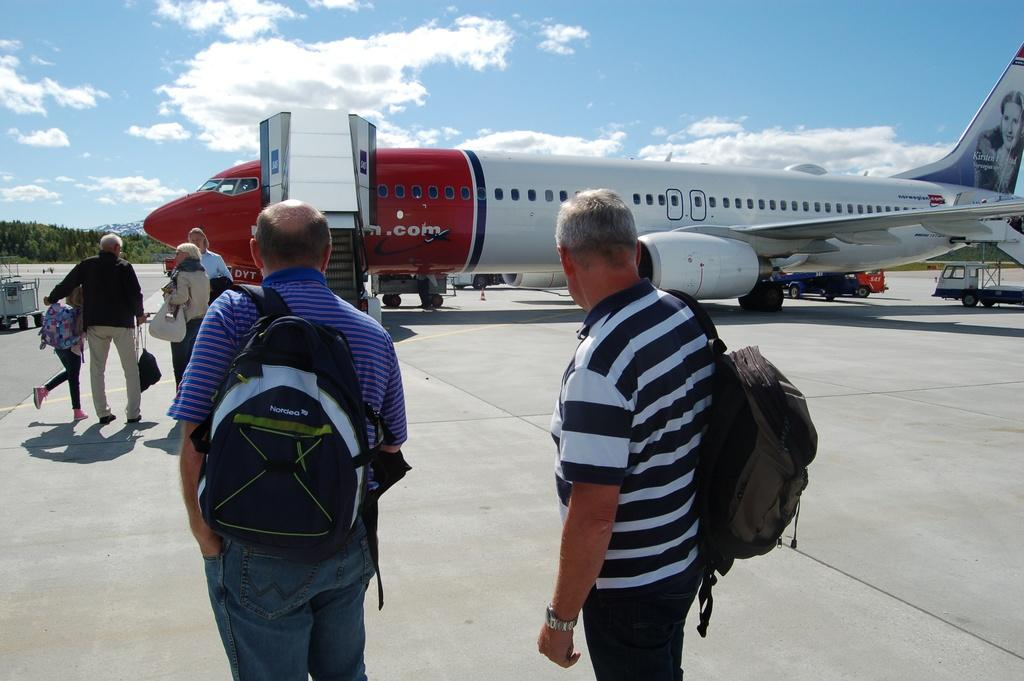<image>
Offer a succinct explanation of the picture presented. A passenger jet has a picture of the Norwegian opera singer Kirsten Flagstad on the tail. 